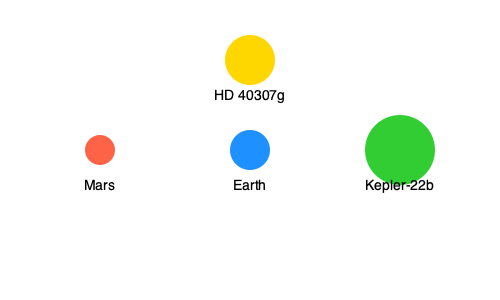Based on the diagram showing the relative sizes of Earth, Mars, Kepler-22b, and HD 40307g, calculate the approximate volume ratio of Kepler-22b to Earth, assuming they are perfect spheres. Express your answer as a simplified fraction. To calculate the volume ratio of Kepler-22b to Earth, we'll follow these steps:

1. Observe the relative sizes in the diagram:
   Earth's radius: 20 units
   Kepler-22b's radius: 35 units

2. Recall the formula for the volume of a sphere: $V = \frac{4}{3}\pi r^3$

3. Set up the volume ratio:
   $\frac{V_{Kepler-22b}}{V_{Earth}} = \frac{\frac{4}{3}\pi r_{Kepler-22b}^3}{\frac{4}{3}\pi r_{Earth}^3}$

4. The $\frac{4}{3}\pi$ cancels out, simplifying to:
   $\frac{V_{Kepler-22b}}{V_{Earth}} = \frac{r_{Kepler-22b}^3}{r_{Earth}^3}$

5. Substitute the radii:
   $\frac{V_{Kepler-22b}}{V_{Earth}} = \frac{35^3}{20^3}$

6. Calculate:
   $\frac{V_{Kepler-22b}}{V_{Earth}} = \frac{42875}{8000} = \frac{343}{64}$

Therefore, the volume ratio of Kepler-22b to Earth is approximately $\frac{343}{64}$.
Answer: $\frac{343}{64}$ 